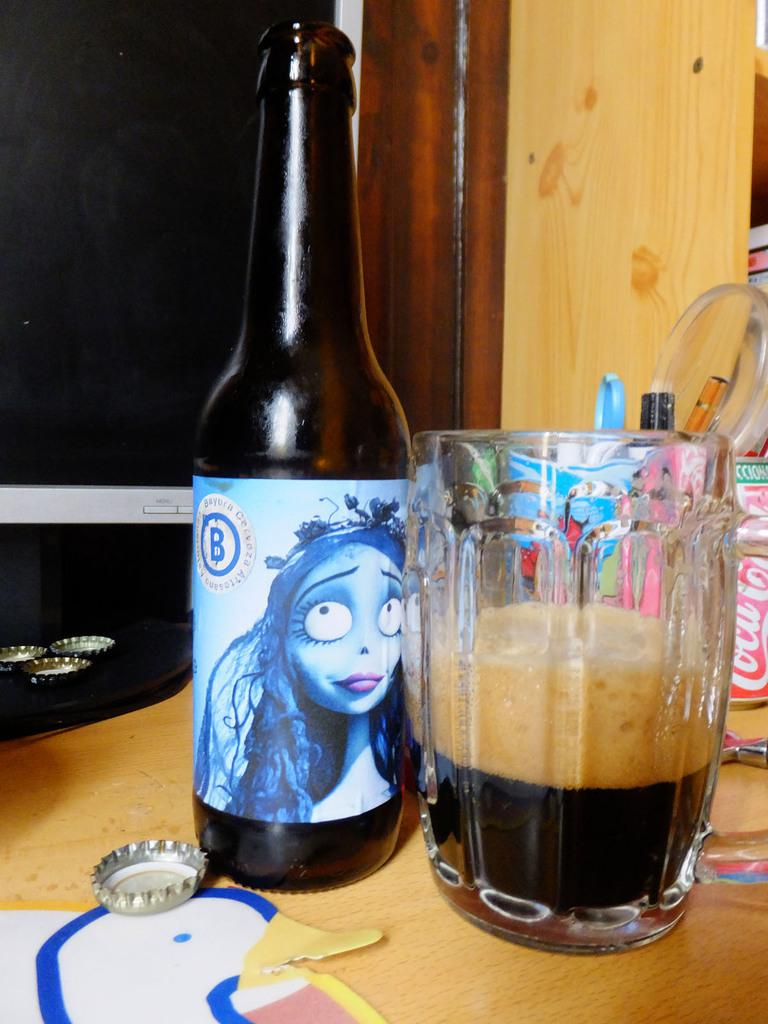What type of table is in the image? There is a wooden table in the image. What is on the wooden table? There is a wine bottle and a glass on the table. Where is the cat sitting in the image? There is no cat present in the image. What type of bread is on the table in the image? There is no bread or loaf present in the image; only a wine bottle and a glass are visible on the table. 